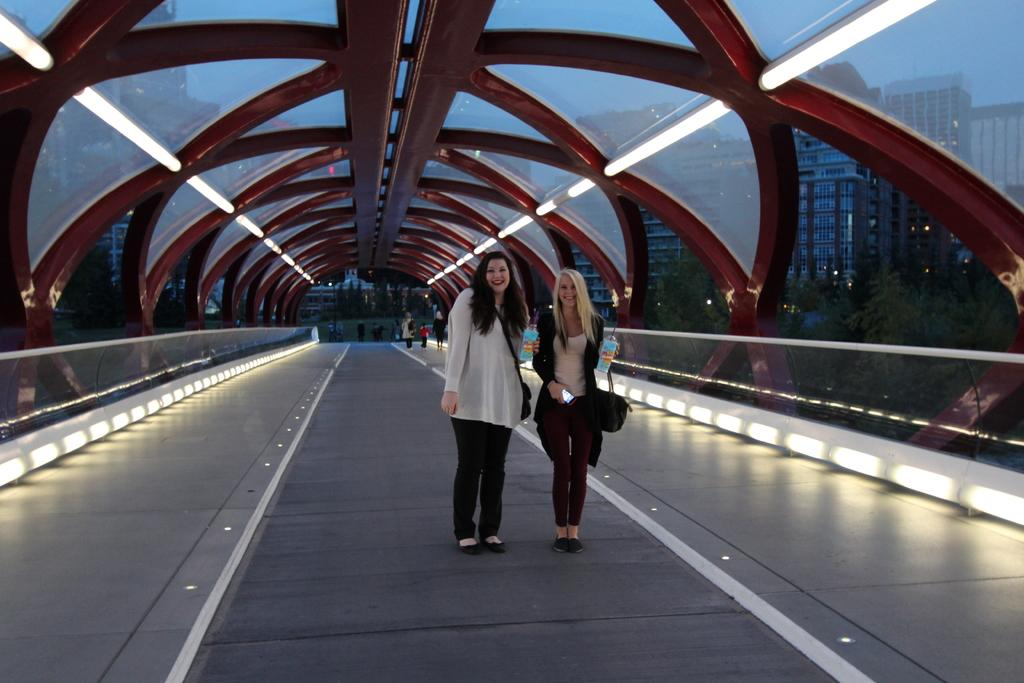How many people are standing on the bridge in the image? There are two persons standing on the bridge in the image. What can be seen in the background of the image? There is a group of people, trees, buildings, and the sky visible in the background of the image. What type of quill is being used by the representative to sign the agreement in the image? There is no representative or agreement present in the image, and therefore no quill can be observed. 